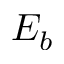Convert formula to latex. <formula><loc_0><loc_0><loc_500><loc_500>E _ { b }</formula> 